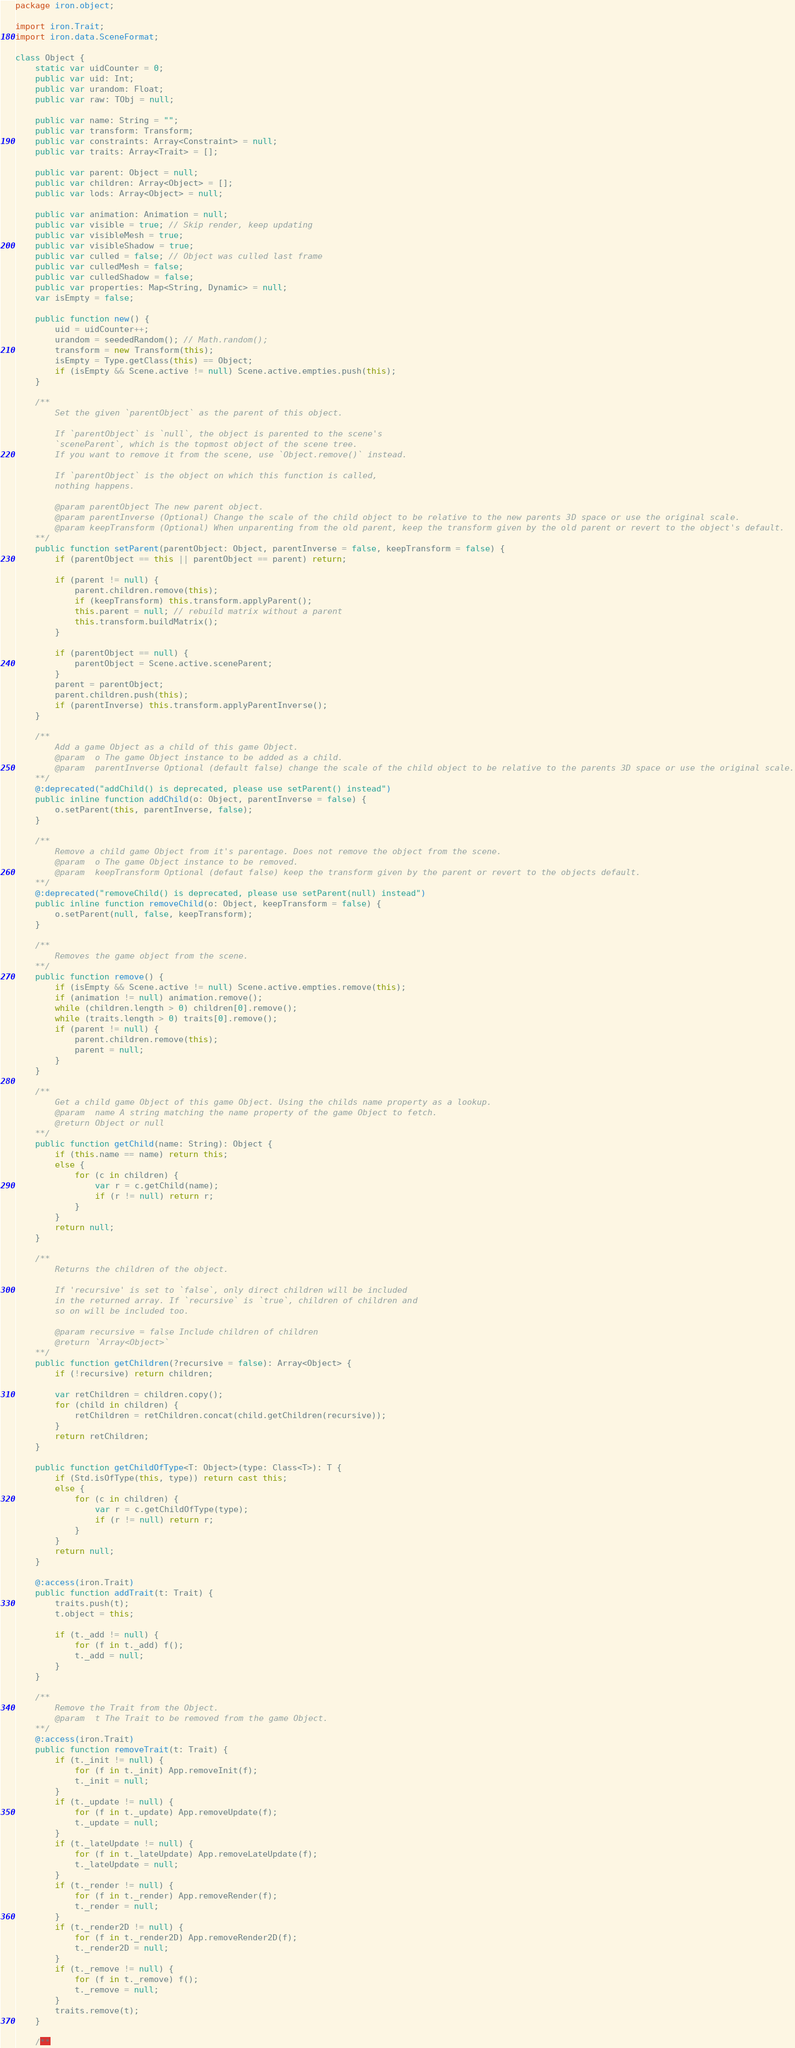Convert code to text. <code><loc_0><loc_0><loc_500><loc_500><_Haxe_>package iron.object;

import iron.Trait;
import iron.data.SceneFormat;

class Object {
	static var uidCounter = 0;
	public var uid: Int;
	public var urandom: Float;
	public var raw: TObj = null;

	public var name: String = "";
	public var transform: Transform;
	public var constraints: Array<Constraint> = null;
	public var traits: Array<Trait> = [];

	public var parent: Object = null;
	public var children: Array<Object> = [];
	public var lods: Array<Object> = null;

	public var animation: Animation = null;
	public var visible = true; // Skip render, keep updating
	public var visibleMesh = true;
	public var visibleShadow = true;
	public var culled = false; // Object was culled last frame
	public var culledMesh = false;
	public var culledShadow = false;
	public var properties: Map<String, Dynamic> = null;
	var isEmpty = false;

	public function new() {
		uid = uidCounter++;
		urandom = seededRandom(); // Math.random();
		transform = new Transform(this);
		isEmpty = Type.getClass(this) == Object;
		if (isEmpty && Scene.active != null) Scene.active.empties.push(this);
	}

	/**
		Set the given `parentObject` as the parent of this object.

		If `parentObject` is `null`, the object is parented to the scene's
		`sceneParent`, which is the topmost object of the scene tree.
		If you want to remove it from the scene, use `Object.remove()` instead.

		If `parentObject` is the object on which this function is called,
		nothing happens.

		@param parentObject The new parent object.
		@param parentInverse (Optional) Change the scale of the child object to be relative to the new parents 3D space or use the original scale.
		@param keepTransform (Optional) When unparenting from the old parent, keep the transform given by the old parent or revert to the object's default.
	**/
	public function setParent(parentObject: Object, parentInverse = false, keepTransform = false) {
		if (parentObject == this || parentObject == parent) return;

		if (parent != null) {
			parent.children.remove(this);
			if (keepTransform) this.transform.applyParent();
			this.parent = null; // rebuild matrix without a parent
			this.transform.buildMatrix();
		}

		if (parentObject == null) {
			parentObject = Scene.active.sceneParent;
		}
		parent = parentObject;
		parent.children.push(this);
		if (parentInverse) this.transform.applyParentInverse();
	}

	/**
		Add a game Object as a child of this game Object.
		@param	o The game Object instance to be added as a child.
		@param	parentInverse Optional (default false) change the scale of the child object to be relative to the parents 3D space or use the original scale.
	**/
	@:deprecated("addChild() is deprecated, please use setParent() instead")
	public inline function addChild(o: Object, parentInverse = false) {
		o.setParent(this, parentInverse, false);
	}

	/**
		Remove a child game Object from it's parentage. Does not remove the object from the scene.
		@param	o The game Object instance to be removed.
		@param	keepTransform Optional (defaut false) keep the transform given by the parent or revert to the objects default.
	**/
	@:deprecated("removeChild() is deprecated, please use setParent(null) instead")
	public inline function removeChild(o: Object, keepTransform = false) {
		o.setParent(null, false, keepTransform);
	}

	/**
		Removes the game object from the scene.
	**/
	public function remove() {
		if (isEmpty && Scene.active != null) Scene.active.empties.remove(this);
		if (animation != null) animation.remove();
		while (children.length > 0) children[0].remove();
		while (traits.length > 0) traits[0].remove();
		if (parent != null) {
			parent.children.remove(this);
			parent = null;
		}
	}

	/**
		Get a child game Object of this game Object. Using the childs name property as a lookup.
		@param	name A string matching the name property of the game Object to fetch.
		@return	Object or null
	**/
	public function getChild(name: String): Object {
		if (this.name == name) return this;
		else {
			for (c in children) {
				var r = c.getChild(name);
				if (r != null) return r;
			}
		}
		return null;
	}

	/**
		Returns the children of the object.

		If 'recursive' is set to `false`, only direct children will be included
		in the returned array. If `recursive` is `true`, children of children and
		so on will be included too.

		@param recursive = false Include children of children
		@return `Array<Object>`
	**/
	public function getChildren(?recursive = false): Array<Object> {
		if (!recursive) return children;

		var retChildren = children.copy();
		for (child in children) {
			retChildren = retChildren.concat(child.getChildren(recursive));
		}
		return retChildren;
	}

	public function getChildOfType<T: Object>(type: Class<T>): T {
		if (Std.isOfType(this, type)) return cast this;
		else {
			for (c in children) {
				var r = c.getChildOfType(type);
				if (r != null) return r;
			}
		}
		return null;
	}

	@:access(iron.Trait)
	public function addTrait(t: Trait) {
		traits.push(t);
		t.object = this;

		if (t._add != null) {
			for (f in t._add) f();
			t._add = null;
		}
	}

	/**
		Remove the Trait from the Object.
		@param	t The Trait to be removed from the game Object.
	**/
	@:access(iron.Trait)
	public function removeTrait(t: Trait) {
		if (t._init != null) {
			for (f in t._init) App.removeInit(f);
			t._init = null;
		}
		if (t._update != null) {
			for (f in t._update) App.removeUpdate(f);
			t._update = null;
		}
		if (t._lateUpdate != null) {
			for (f in t._lateUpdate) App.removeLateUpdate(f);
			t._lateUpdate = null;
		}
		if (t._render != null) {
			for (f in t._render) App.removeRender(f);
			t._render = null;
		}
		if (t._render2D != null) {
			for (f in t._render2D) App.removeRender2D(f);
			t._render2D = null;
		}
		if (t._remove != null) {
			for (f in t._remove) f();
			t._remove = null;
		}
		traits.remove(t);
	}

	/**</code> 